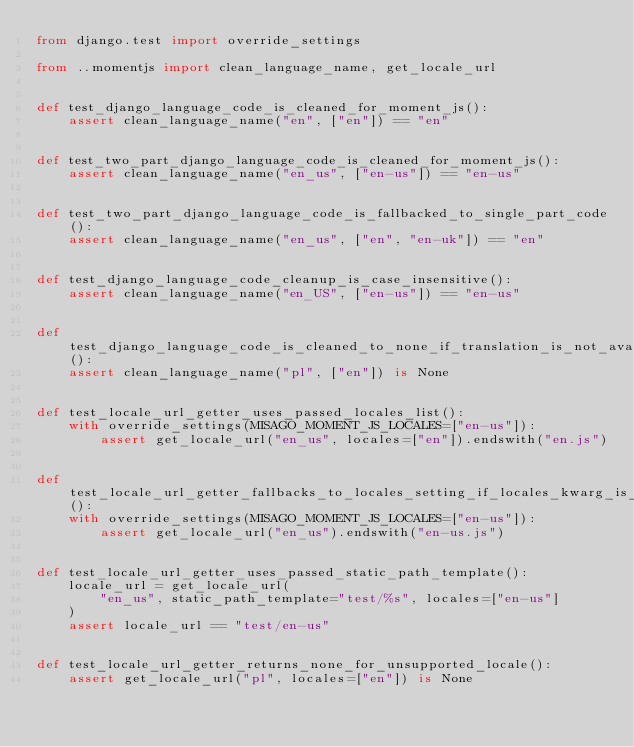<code> <loc_0><loc_0><loc_500><loc_500><_Python_>from django.test import override_settings

from ..momentjs import clean_language_name, get_locale_url


def test_django_language_code_is_cleaned_for_moment_js():
    assert clean_language_name("en", ["en"]) == "en"


def test_two_part_django_language_code_is_cleaned_for_moment_js():
    assert clean_language_name("en_us", ["en-us"]) == "en-us"


def test_two_part_django_language_code_is_fallbacked_to_single_part_code():
    assert clean_language_name("en_us", ["en", "en-uk"]) == "en"


def test_django_language_code_cleanup_is_case_insensitive():
    assert clean_language_name("en_US", ["en-us"]) == "en-us"


def test_django_language_code_is_cleaned_to_none_if_translation_is_not_available():
    assert clean_language_name("pl", ["en"]) is None


def test_locale_url_getter_uses_passed_locales_list():
    with override_settings(MISAGO_MOMENT_JS_LOCALES=["en-us"]):
        assert get_locale_url("en_us", locales=["en"]).endswith("en.js")


def test_locale_url_getter_fallbacks_to_locales_setting_if_locales_kwarg_is_not_set():
    with override_settings(MISAGO_MOMENT_JS_LOCALES=["en-us"]):
        assert get_locale_url("en_us").endswith("en-us.js")


def test_locale_url_getter_uses_passed_static_path_template():
    locale_url = get_locale_url(
        "en_us", static_path_template="test/%s", locales=["en-us"]
    )
    assert locale_url == "test/en-us"


def test_locale_url_getter_returns_none_for_unsupported_locale():
    assert get_locale_url("pl", locales=["en"]) is None
</code> 